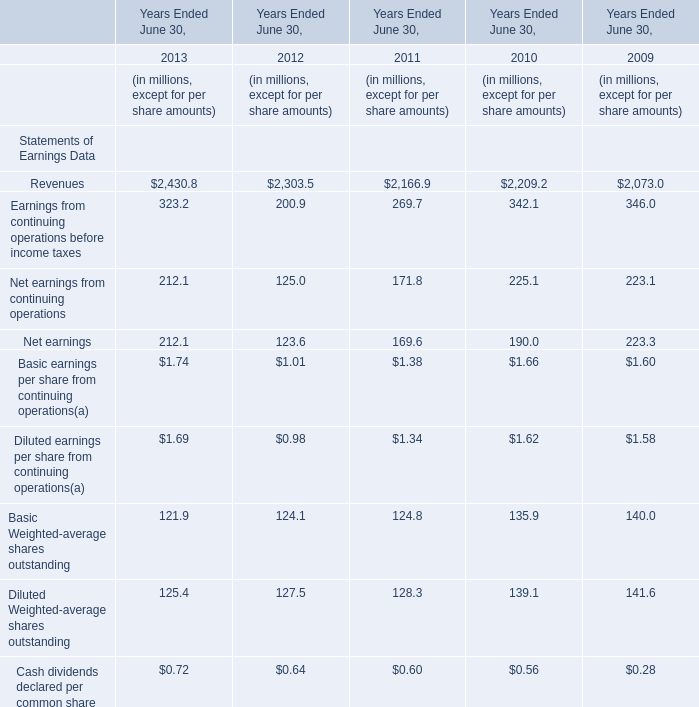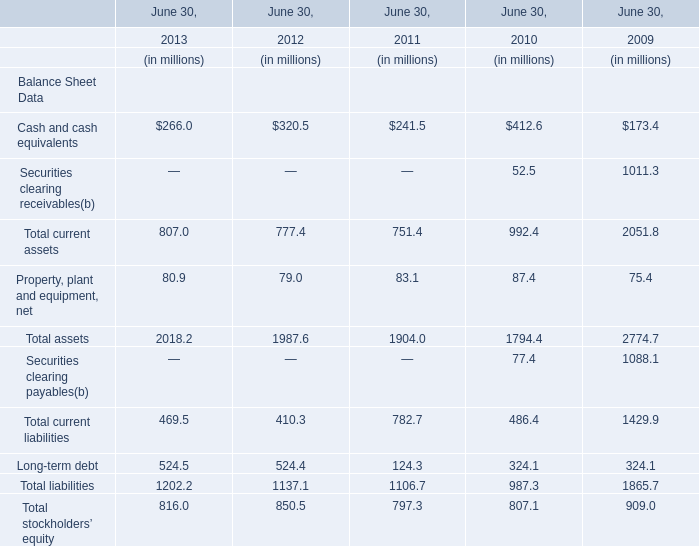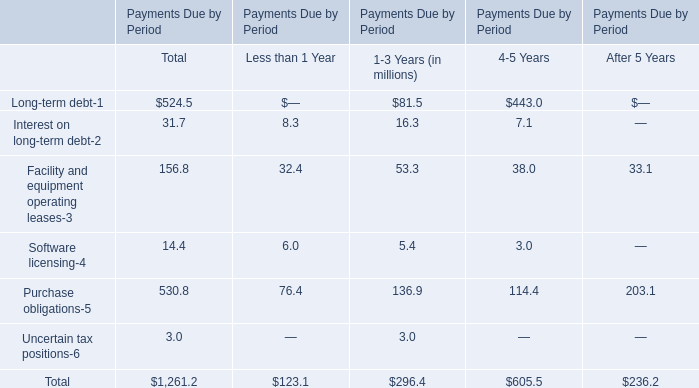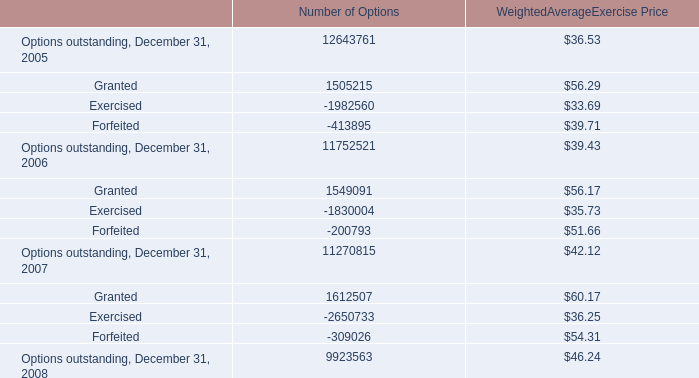what is the growth rate of the weighted average exercise price of options from december 31 , 2005 to december 31 , 2008? 
Computations: ((46.24 - 36.53) / 36.53)
Answer: 0.26581. 